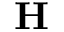<formula> <loc_0><loc_0><loc_500><loc_500>H</formula> 